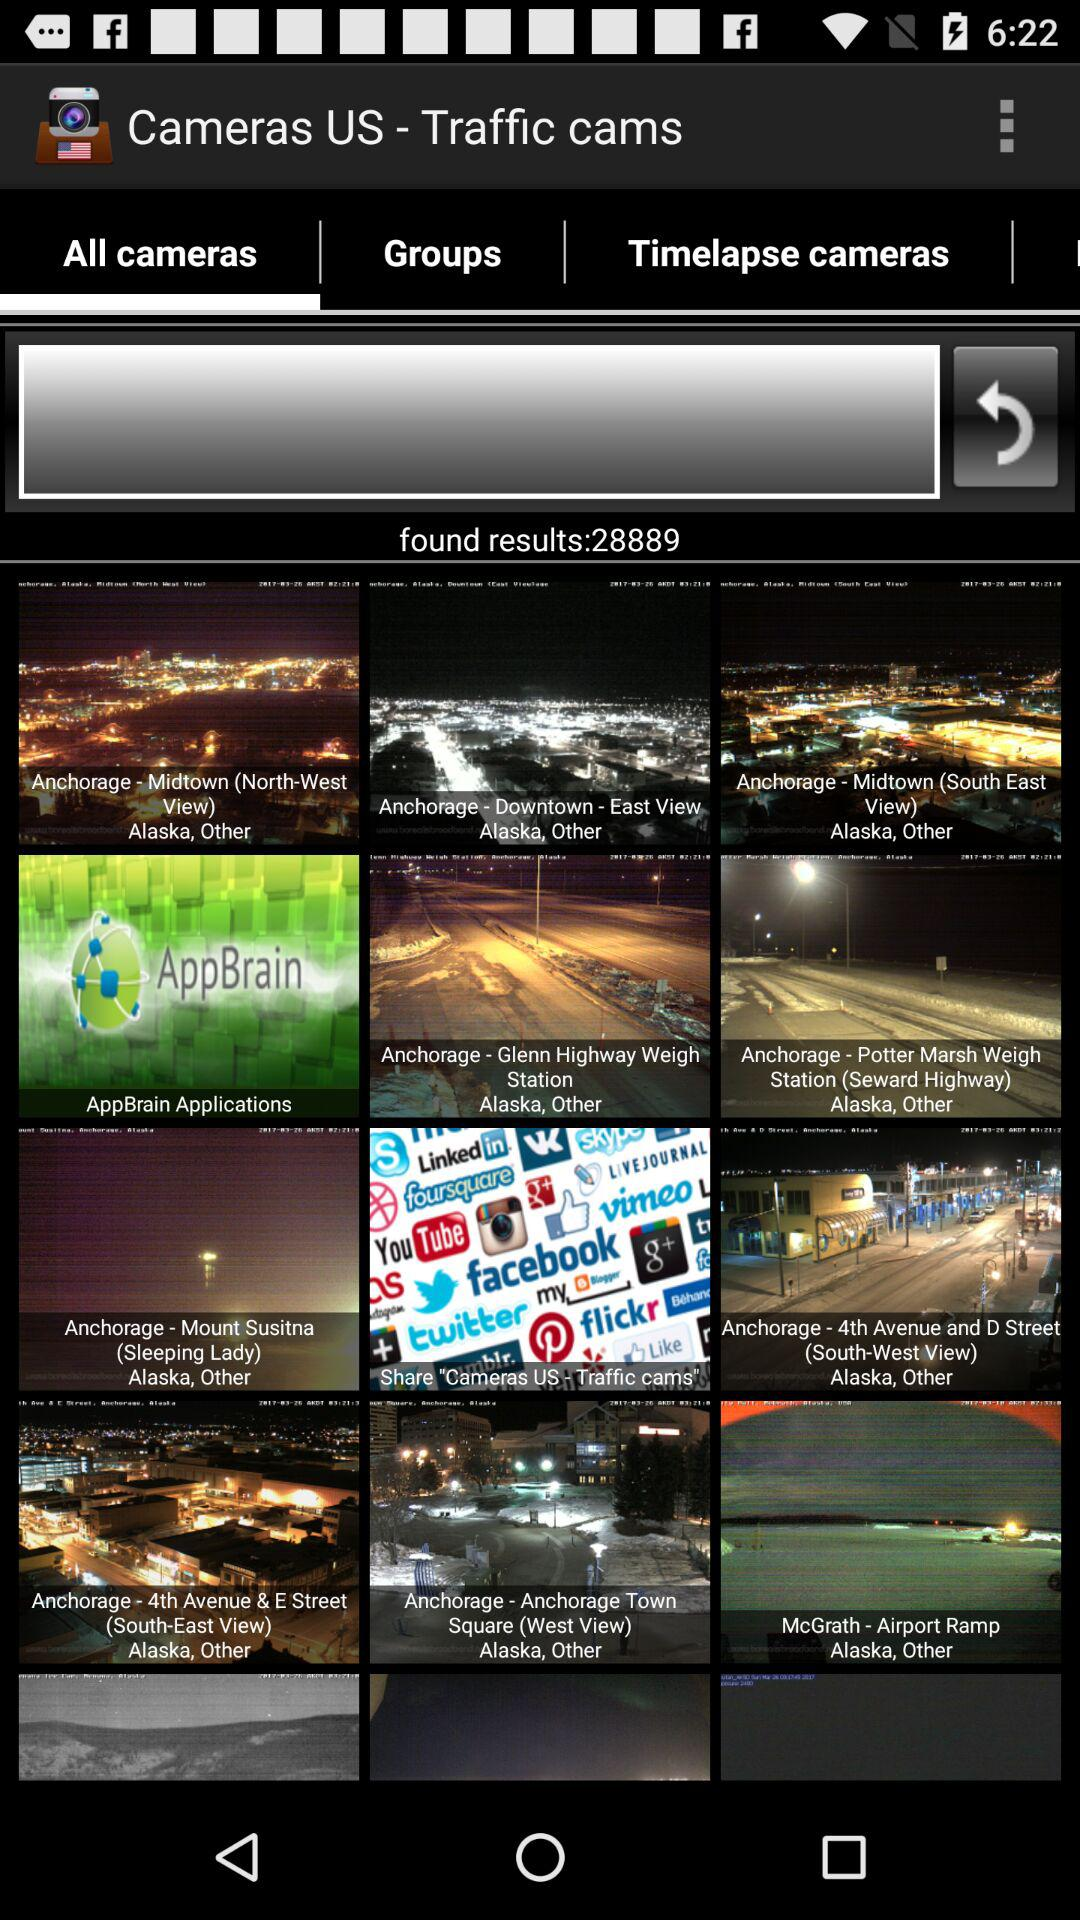Which option is selected? The selected option is "All cameras". 